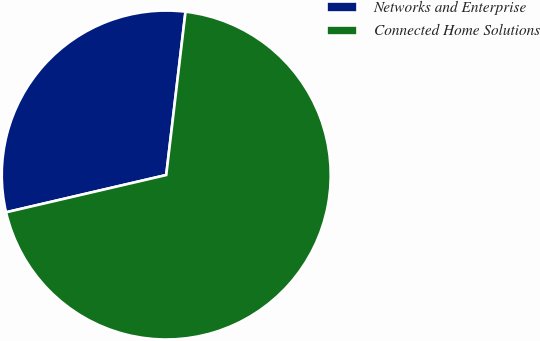<chart> <loc_0><loc_0><loc_500><loc_500><pie_chart><fcel>Networks and Enterprise<fcel>Connected Home Solutions<nl><fcel>30.51%<fcel>69.49%<nl></chart> 